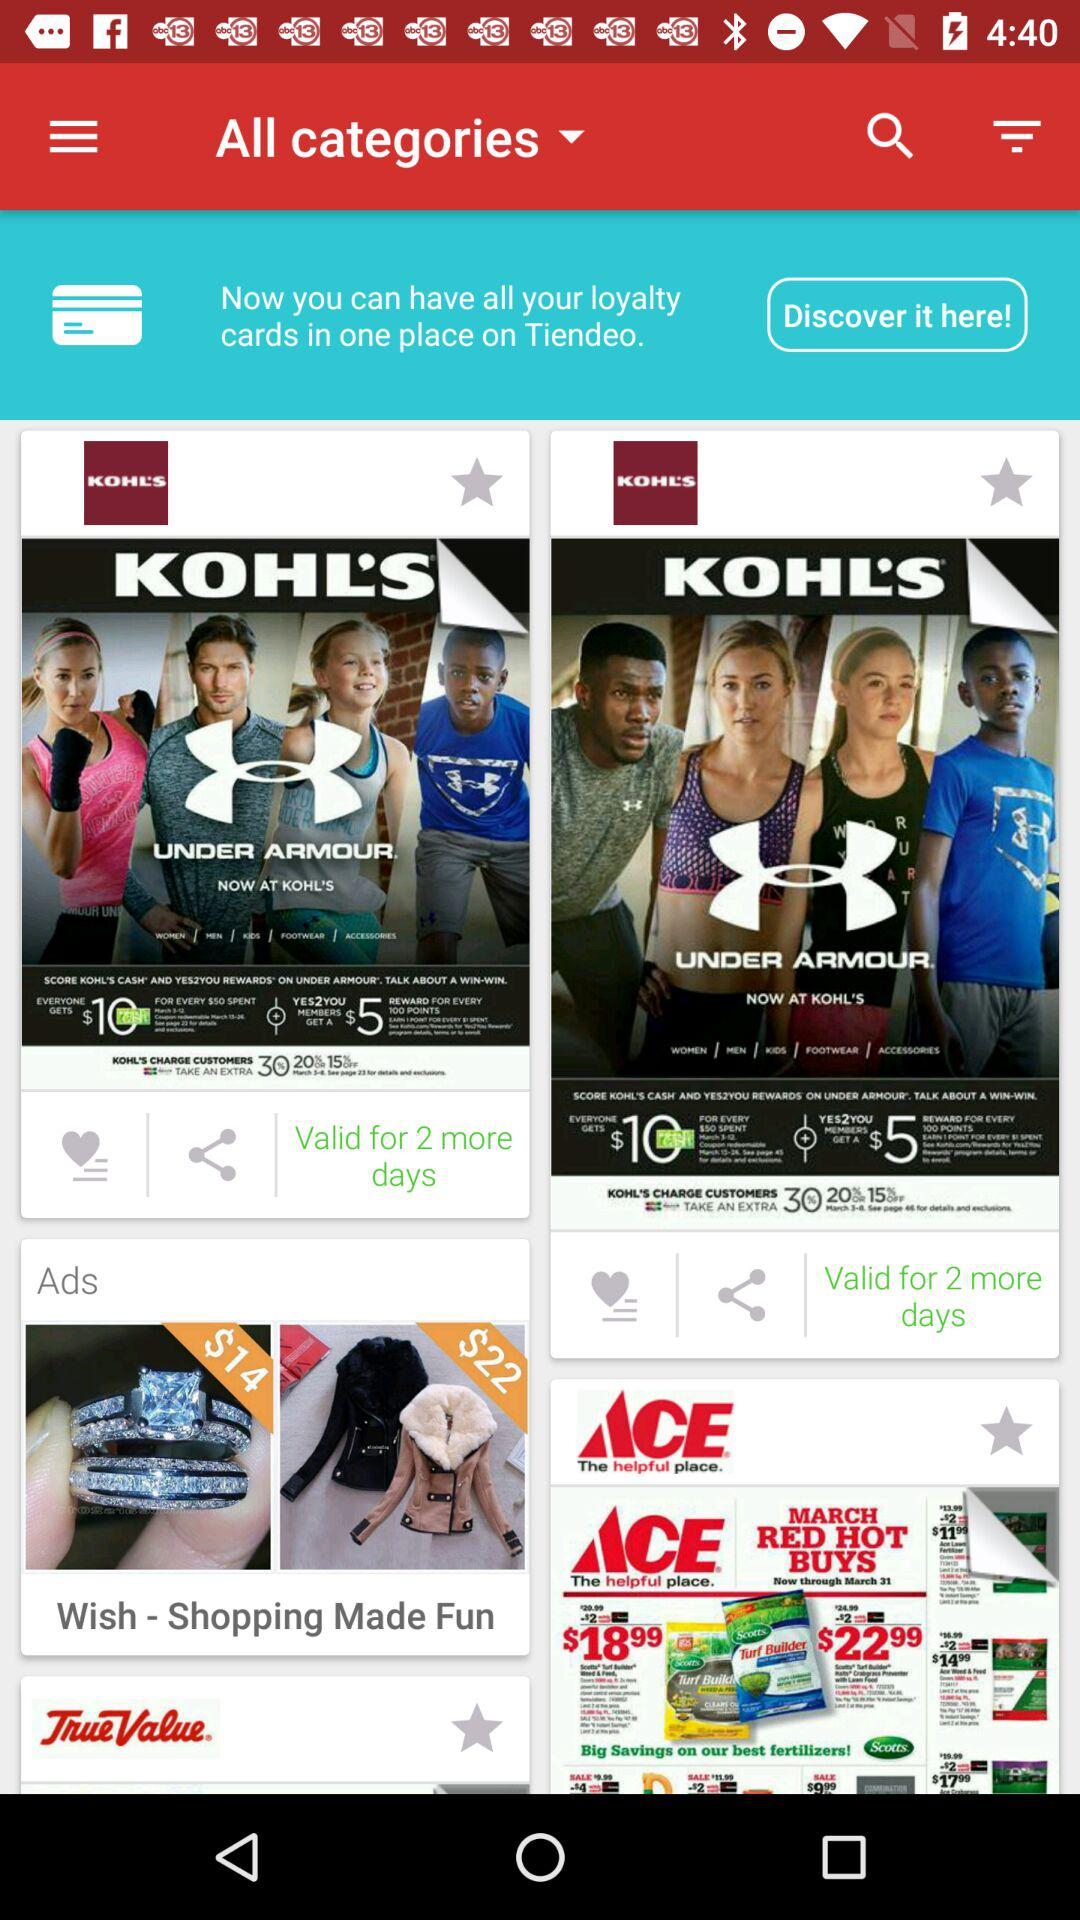What is the shopping platform name? The shopping platform names are "KOHL'S", "ACE" and "TrueValue". 